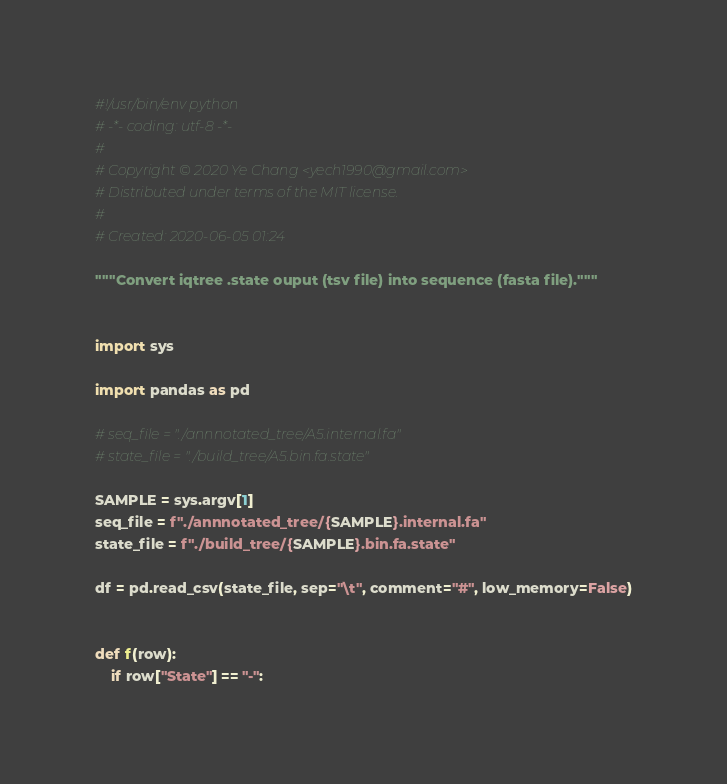<code> <loc_0><loc_0><loc_500><loc_500><_Python_>#!/usr/bin/env python
# -*- coding: utf-8 -*-
#
# Copyright © 2020 Ye Chang <yech1990@gmail.com>
# Distributed under terms of the MIT license.
#
# Created: 2020-06-05 01:24

"""Convert iqtree .state ouput (tsv file) into sequence (fasta file)."""


import sys

import pandas as pd

# seq_file = "./annnotated_tree/A5.internal.fa"
# state_file = "./build_tree/A5.bin.fa.state"

SAMPLE = sys.argv[1]
seq_file = f"./annnotated_tree/{SAMPLE}.internal.fa"
state_file = f"./build_tree/{SAMPLE}.bin.fa.state"

df = pd.read_csv(state_file, sep="\t", comment="#", low_memory=False)


def f(row):
    if row["State"] == "-":</code> 